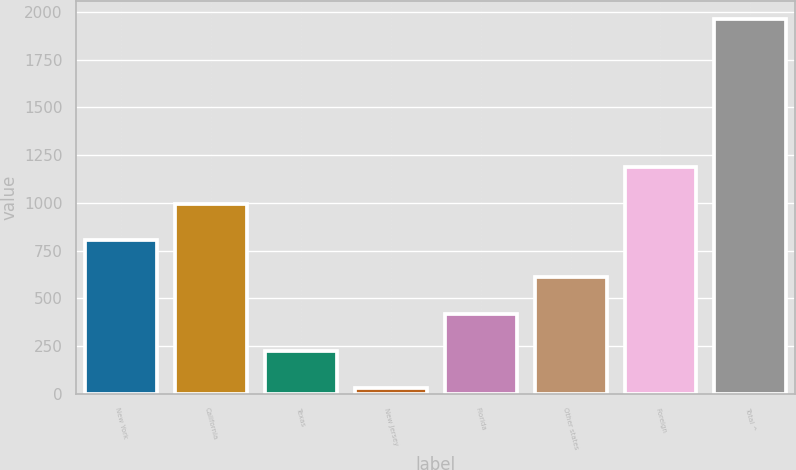Convert chart to OTSL. <chart><loc_0><loc_0><loc_500><loc_500><bar_chart><fcel>New York<fcel>California<fcel>Texas<fcel>New Jersey<fcel>Florida<fcel>Other states<fcel>Foreign<fcel>Total ^<nl><fcel>803.2<fcel>996<fcel>224.8<fcel>32<fcel>417.6<fcel>610.4<fcel>1188.8<fcel>1960<nl></chart> 